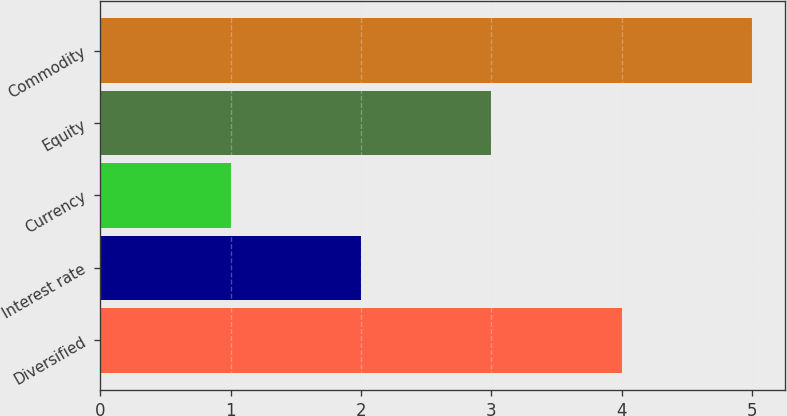Convert chart. <chart><loc_0><loc_0><loc_500><loc_500><bar_chart><fcel>Diversified<fcel>Interest rate<fcel>Currency<fcel>Equity<fcel>Commodity<nl><fcel>4<fcel>2<fcel>1<fcel>3<fcel>5<nl></chart> 